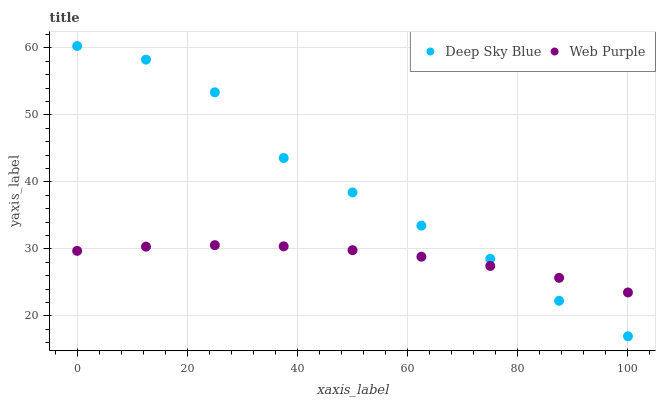Does Web Purple have the minimum area under the curve?
Answer yes or no. Yes. Does Deep Sky Blue have the maximum area under the curve?
Answer yes or no. Yes. Does Deep Sky Blue have the minimum area under the curve?
Answer yes or no. No. Is Web Purple the smoothest?
Answer yes or no. Yes. Is Deep Sky Blue the roughest?
Answer yes or no. Yes. Is Deep Sky Blue the smoothest?
Answer yes or no. No. Does Deep Sky Blue have the lowest value?
Answer yes or no. Yes. Does Deep Sky Blue have the highest value?
Answer yes or no. Yes. Does Deep Sky Blue intersect Web Purple?
Answer yes or no. Yes. Is Deep Sky Blue less than Web Purple?
Answer yes or no. No. Is Deep Sky Blue greater than Web Purple?
Answer yes or no. No. 